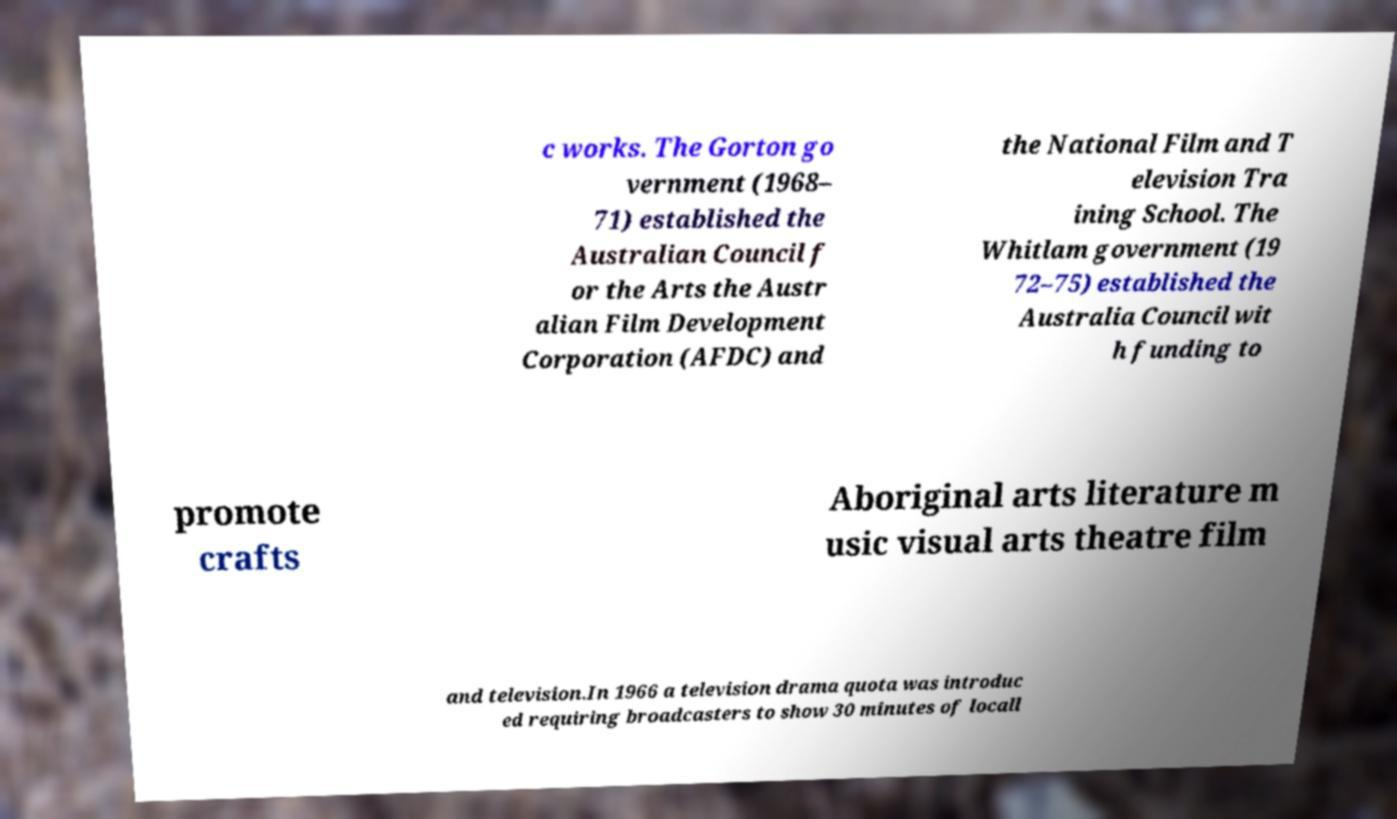Can you accurately transcribe the text from the provided image for me? c works. The Gorton go vernment (1968– 71) established the Australian Council f or the Arts the Austr alian Film Development Corporation (AFDC) and the National Film and T elevision Tra ining School. The Whitlam government (19 72–75) established the Australia Council wit h funding to promote crafts Aboriginal arts literature m usic visual arts theatre film and television.In 1966 a television drama quota was introduc ed requiring broadcasters to show 30 minutes of locall 